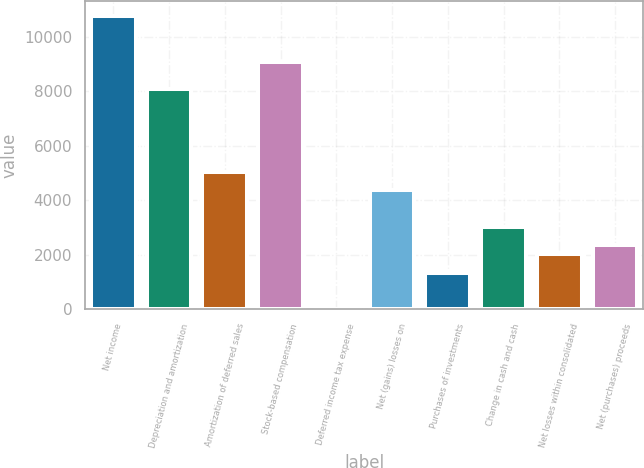<chart> <loc_0><loc_0><loc_500><loc_500><bar_chart><fcel>Net income<fcel>Depreciation and amortization<fcel>Amortization of deferred sales<fcel>Stock-based compensation<fcel>Deferred income tax expense<fcel>Net (gains) losses on<fcel>Purchases of investments<fcel>Change in cash and cash<fcel>Net losses within consolidated<fcel>Net (purchases) proceeds<nl><fcel>10767.8<fcel>8076.6<fcel>5049<fcel>9085.8<fcel>3<fcel>4376.2<fcel>1348.6<fcel>3030.6<fcel>2021.4<fcel>2357.8<nl></chart> 